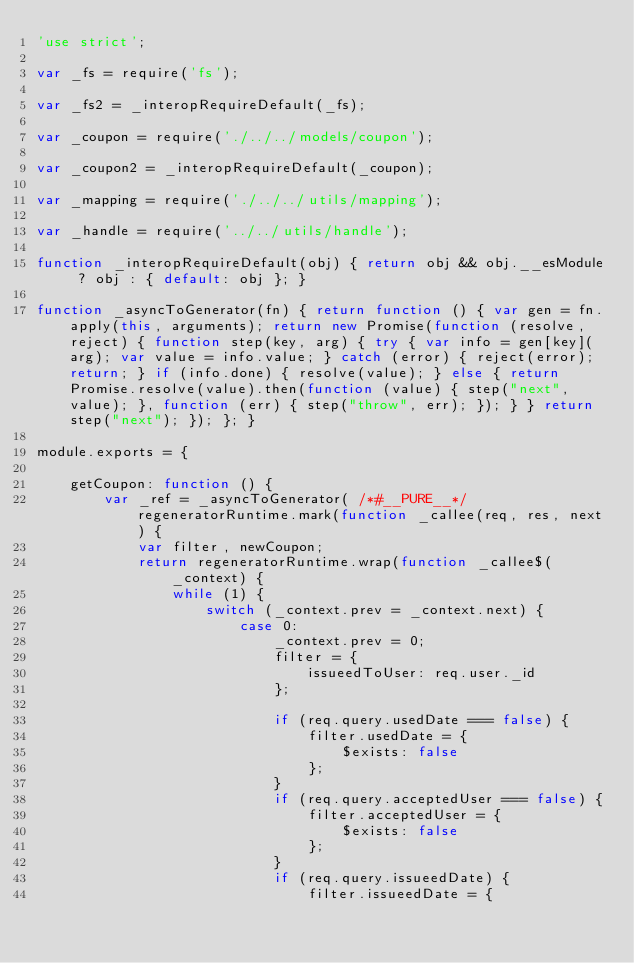Convert code to text. <code><loc_0><loc_0><loc_500><loc_500><_JavaScript_>'use strict';

var _fs = require('fs');

var _fs2 = _interopRequireDefault(_fs);

var _coupon = require('./../../models/coupon');

var _coupon2 = _interopRequireDefault(_coupon);

var _mapping = require('./../../utils/mapping');

var _handle = require('../../utils/handle');

function _interopRequireDefault(obj) { return obj && obj.__esModule ? obj : { default: obj }; }

function _asyncToGenerator(fn) { return function () { var gen = fn.apply(this, arguments); return new Promise(function (resolve, reject) { function step(key, arg) { try { var info = gen[key](arg); var value = info.value; } catch (error) { reject(error); return; } if (info.done) { resolve(value); } else { return Promise.resolve(value).then(function (value) { step("next", value); }, function (err) { step("throw", err); }); } } return step("next"); }); }; }

module.exports = {

    getCoupon: function () {
        var _ref = _asyncToGenerator( /*#__PURE__*/regeneratorRuntime.mark(function _callee(req, res, next) {
            var filter, newCoupon;
            return regeneratorRuntime.wrap(function _callee$(_context) {
                while (1) {
                    switch (_context.prev = _context.next) {
                        case 0:
                            _context.prev = 0;
                            filter = {
                                issueedToUser: req.user._id
                            };

                            if (req.query.usedDate === false) {
                                filter.usedDate = {
                                    $exists: false
                                };
                            }
                            if (req.query.acceptedUser === false) {
                                filter.acceptedUser = {
                                    $exists: false
                                };
                            }
                            if (req.query.issueedDate) {
                                filter.issueedDate = {</code> 